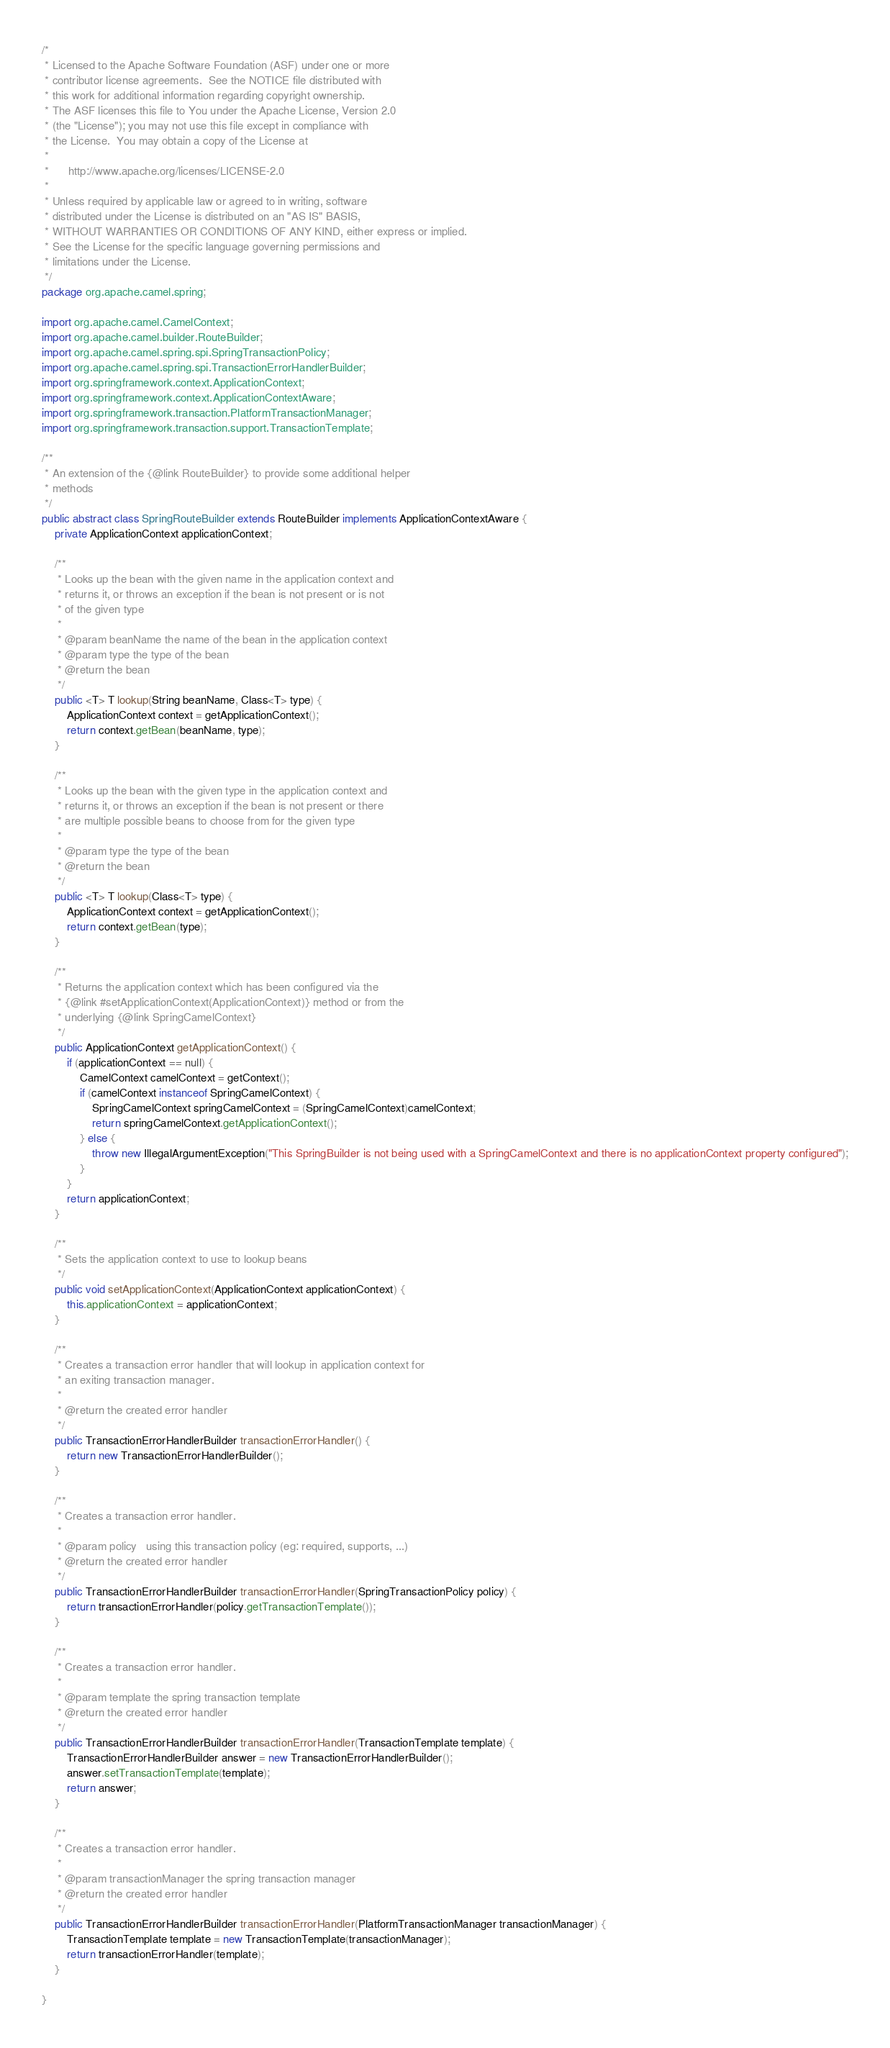Convert code to text. <code><loc_0><loc_0><loc_500><loc_500><_Java_>/*
 * Licensed to the Apache Software Foundation (ASF) under one or more
 * contributor license agreements.  See the NOTICE file distributed with
 * this work for additional information regarding copyright ownership.
 * The ASF licenses this file to You under the Apache License, Version 2.0
 * (the "License"); you may not use this file except in compliance with
 * the License.  You may obtain a copy of the License at
 *
 *      http://www.apache.org/licenses/LICENSE-2.0
 *
 * Unless required by applicable law or agreed to in writing, software
 * distributed under the License is distributed on an "AS IS" BASIS,
 * WITHOUT WARRANTIES OR CONDITIONS OF ANY KIND, either express or implied.
 * See the License for the specific language governing permissions and
 * limitations under the License.
 */
package org.apache.camel.spring;

import org.apache.camel.CamelContext;
import org.apache.camel.builder.RouteBuilder;
import org.apache.camel.spring.spi.SpringTransactionPolicy;
import org.apache.camel.spring.spi.TransactionErrorHandlerBuilder;
import org.springframework.context.ApplicationContext;
import org.springframework.context.ApplicationContextAware;
import org.springframework.transaction.PlatformTransactionManager;
import org.springframework.transaction.support.TransactionTemplate;

/**
 * An extension of the {@link RouteBuilder} to provide some additional helper
 * methods
 */
public abstract class SpringRouteBuilder extends RouteBuilder implements ApplicationContextAware {
    private ApplicationContext applicationContext;

    /**
     * Looks up the bean with the given name in the application context and
     * returns it, or throws an exception if the bean is not present or is not
     * of the given type
     *
     * @param beanName the name of the bean in the application context
     * @param type the type of the bean
     * @return the bean
     */
    public <T> T lookup(String beanName, Class<T> type) {
        ApplicationContext context = getApplicationContext();
        return context.getBean(beanName, type);
    }

    /**
     * Looks up the bean with the given type in the application context and
     * returns it, or throws an exception if the bean is not present or there
     * are multiple possible beans to choose from for the given type
     *
     * @param type the type of the bean
     * @return the bean
     */
    public <T> T lookup(Class<T> type) {
        ApplicationContext context = getApplicationContext();
        return context.getBean(type);
    }

    /**
     * Returns the application context which has been configured via the
     * {@link #setApplicationContext(ApplicationContext)} method or from the
     * underlying {@link SpringCamelContext}
     */
    public ApplicationContext getApplicationContext() {
        if (applicationContext == null) {
            CamelContext camelContext = getContext();
            if (camelContext instanceof SpringCamelContext) {
                SpringCamelContext springCamelContext = (SpringCamelContext)camelContext;
                return springCamelContext.getApplicationContext();
            } else {
                throw new IllegalArgumentException("This SpringBuilder is not being used with a SpringCamelContext and there is no applicationContext property configured");
            }
        }
        return applicationContext;
    }

    /**
     * Sets the application context to use to lookup beans
     */
    public void setApplicationContext(ApplicationContext applicationContext) {        
        this.applicationContext = applicationContext;
    }

    /**
     * Creates a transaction error handler that will lookup in application context for
     * an exiting transaction manager.
     *
     * @return the created error handler
     */
    public TransactionErrorHandlerBuilder transactionErrorHandler() {
        return new TransactionErrorHandlerBuilder();
    }

    /**
     * Creates a transaction error handler.
     *
     * @param policy   using this transaction policy (eg: required, supports, ...)
     * @return the created error handler
     */
    public TransactionErrorHandlerBuilder transactionErrorHandler(SpringTransactionPolicy policy) {
        return transactionErrorHandler(policy.getTransactionTemplate());
    }

    /**
     * Creates a transaction error handler.
     *
     * @param template the spring transaction template
     * @return the created error handler
     */
    public TransactionErrorHandlerBuilder transactionErrorHandler(TransactionTemplate template) {
        TransactionErrorHandlerBuilder answer = new TransactionErrorHandlerBuilder();
        answer.setTransactionTemplate(template);
        return answer;
    }

    /**
     * Creates a transaction error handler.
     *
     * @param transactionManager the spring transaction manager
     * @return the created error handler
     */
    public TransactionErrorHandlerBuilder transactionErrorHandler(PlatformTransactionManager transactionManager) {
        TransactionTemplate template = new TransactionTemplate(transactionManager);
        return transactionErrorHandler(template);
    }

}
</code> 